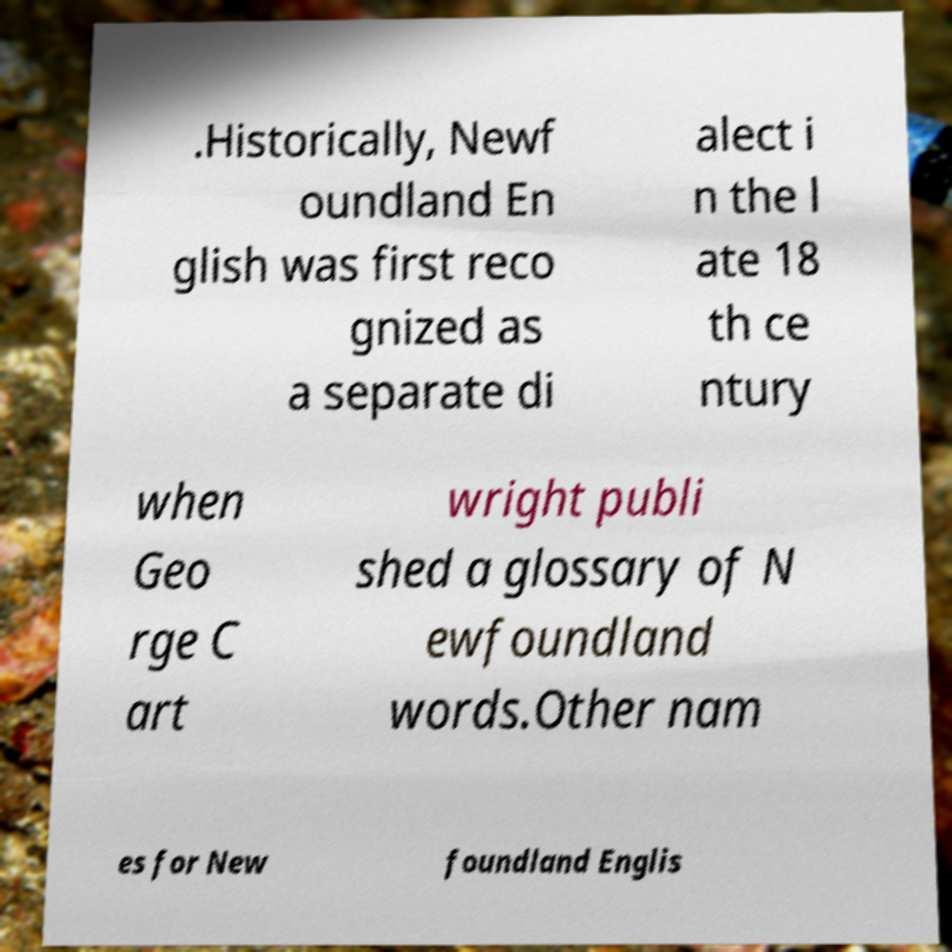Please read and relay the text visible in this image. What does it say? .Historically, Newf oundland En glish was first reco gnized as a separate di alect i n the l ate 18 th ce ntury when Geo rge C art wright publi shed a glossary of N ewfoundland words.Other nam es for New foundland Englis 